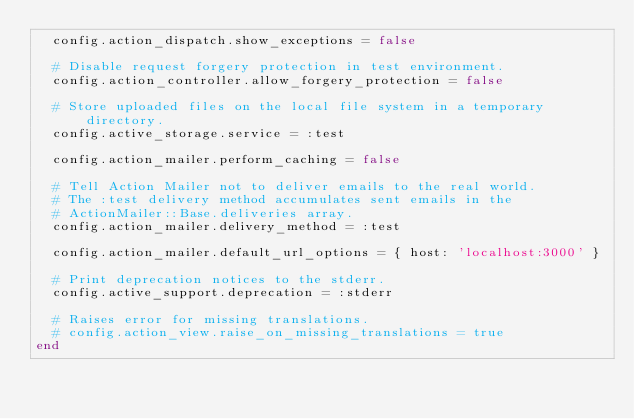<code> <loc_0><loc_0><loc_500><loc_500><_Ruby_>  config.action_dispatch.show_exceptions = false

  # Disable request forgery protection in test environment.
  config.action_controller.allow_forgery_protection = false

  # Store uploaded files on the local file system in a temporary directory.
  config.active_storage.service = :test

  config.action_mailer.perform_caching = false

  # Tell Action Mailer not to deliver emails to the real world.
  # The :test delivery method accumulates sent emails in the
  # ActionMailer::Base.deliveries array.
  config.action_mailer.delivery_method = :test

  config.action_mailer.default_url_options = { host: 'localhost:3000' }

  # Print deprecation notices to the stderr.
  config.active_support.deprecation = :stderr

  # Raises error for missing translations.
  # config.action_view.raise_on_missing_translations = true
end
</code> 